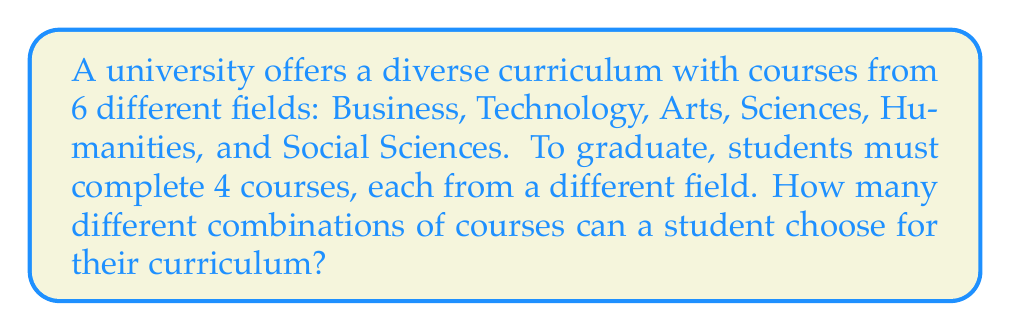Solve this math problem. Let's approach this step-by-step:

1) First, we need to choose 4 fields out of the 6 available. This can be done using the combination formula:

   $${6 \choose 4} = \frac{6!}{4!(6-4)!} = \frac{6!}{4!2!} = 15$$

2) Now, for each of these 15 combinations of fields, we need to choose one course from each field.

3) Let's assume each field offers $n$ courses. The number of ways to choose one course from each of the 4 selected fields would be $n^4$.

4) However, since we're not given the number of courses in each field, we can't calculate the final number. We can express it as:

   $$15 \cdot n^4$$

5) This formula represents the total number of possible course combinations:
   - 15 ways to choose 4 fields out of 6
   - $n$ choices for each of the 4 fields

This approach allows for a diverse curriculum by ensuring courses are taken from different fields, aligning with the business executive's encouragement to explore various majors.
Answer: $15n^4$, where $n$ is the number of courses in each field 